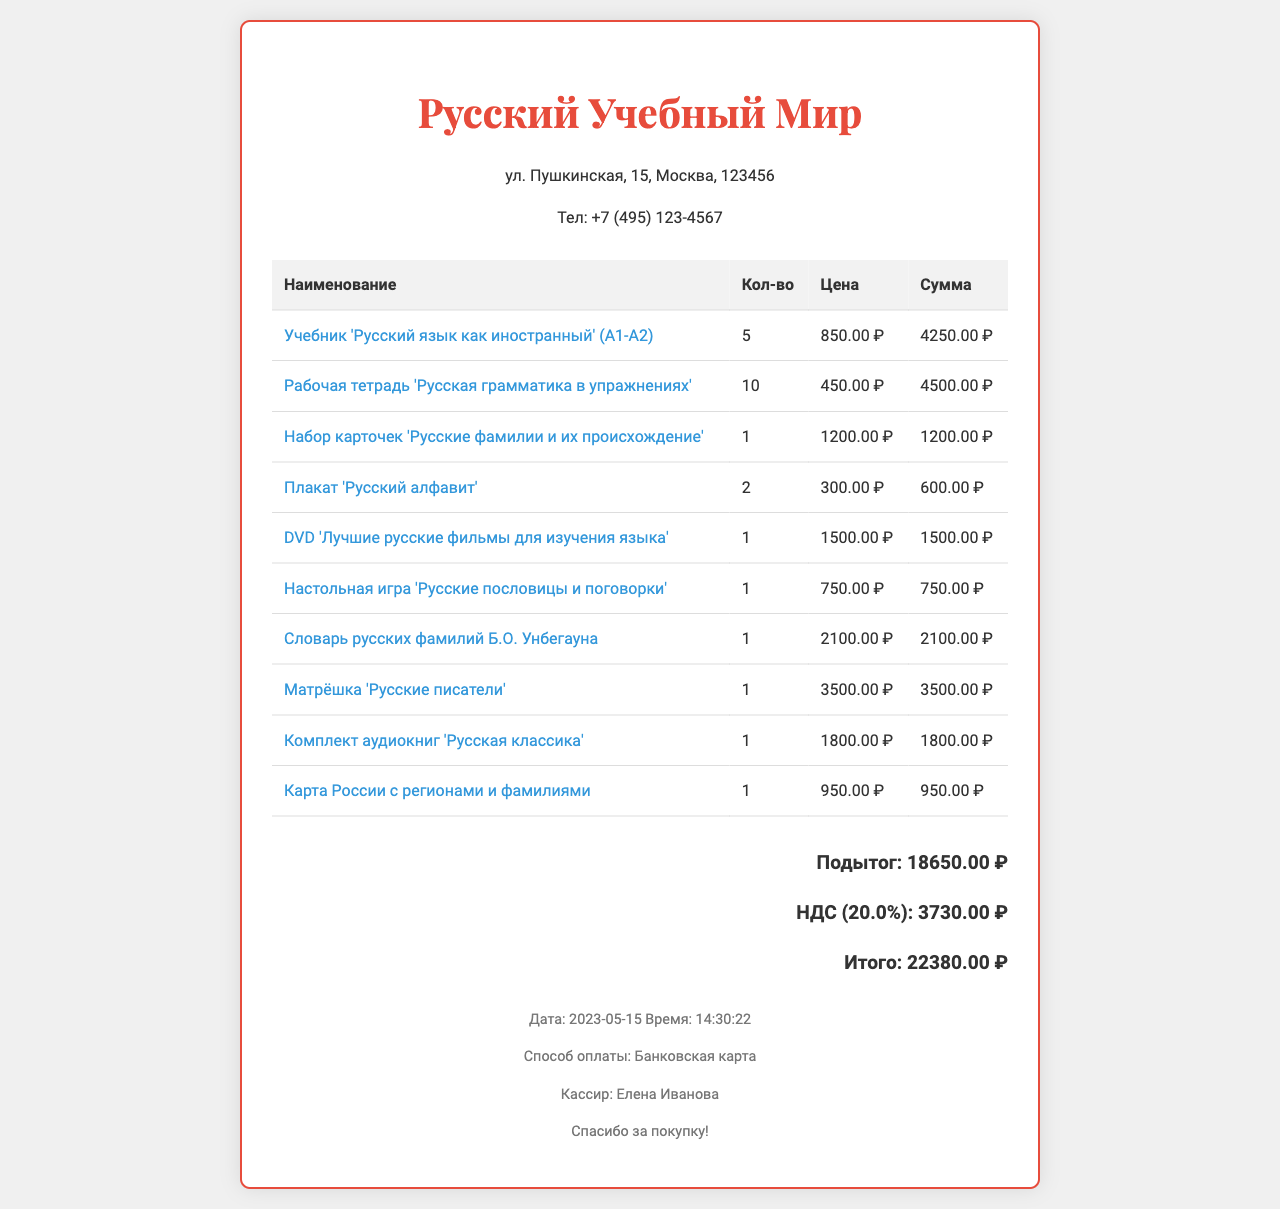What is the name of the store? The store name is prominently displayed at the top of the receipt.
Answer: Русский Учебный Мир What is the address of the store? The store address is listed below the store name in the document.
Answer: ул. Пушкинская, 15, Москва, 123456 What item has the highest price? By comparing the prices of items listed, the highest price can be identified.
Answer: Матрёшка 'Русские писатели' What is the total amount paid? The total amount is calculated including the subtotal and tax, clearly presented at the end of the receipt.
Answer: 22380.00 ₽ How many 'Рабочая тетрадь' were purchased? The quantity for each item is displayed in the itemized list, allowing for quick retrieval of the number of specific items.
Answer: 10 What is the tax rate applied? The tax rate is explicitly mentioned in the total calculation section of the receipt.
Answer: 20% Who was the cashier? The cashier's name is stated in the footer section of the receipt.
Answer: Елена Иванова What item is related to Russian surnames? Referring to the item titles to find items specifically related to surnames.
Answer: Набор карточек 'Русские фамилии и их происхождение' What was the payment method used? The payment method is detailed in the footer section of the receipt.
Answer: Банковская карта 